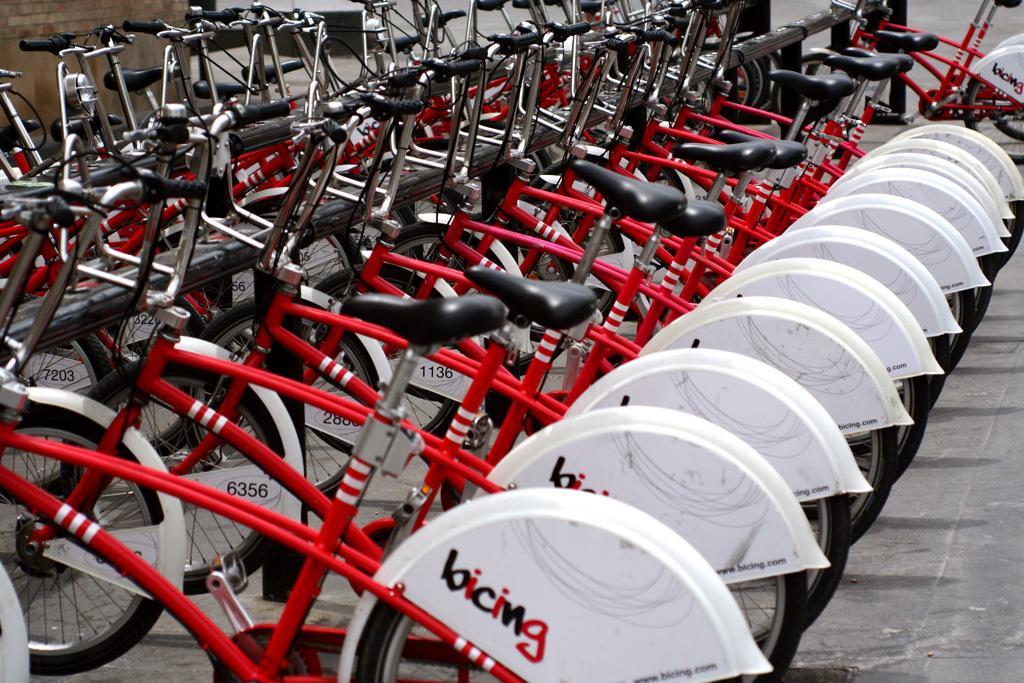Can you describe this image briefly? In this picture I can see bicycles, these bicycles are red and white in color. I can see something written on them. 